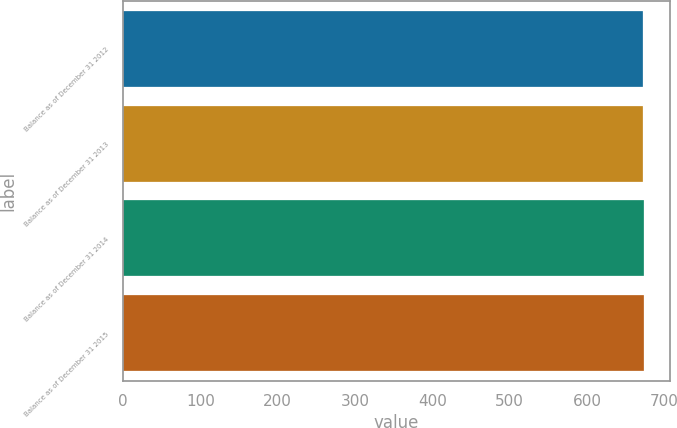Convert chart to OTSL. <chart><loc_0><loc_0><loc_500><loc_500><bar_chart><fcel>Balance as of December 31 2012<fcel>Balance as of December 31 2013<fcel>Balance as of December 31 2014<fcel>Balance as of December 31 2015<nl><fcel>673<fcel>673.1<fcel>673.2<fcel>673.3<nl></chart> 